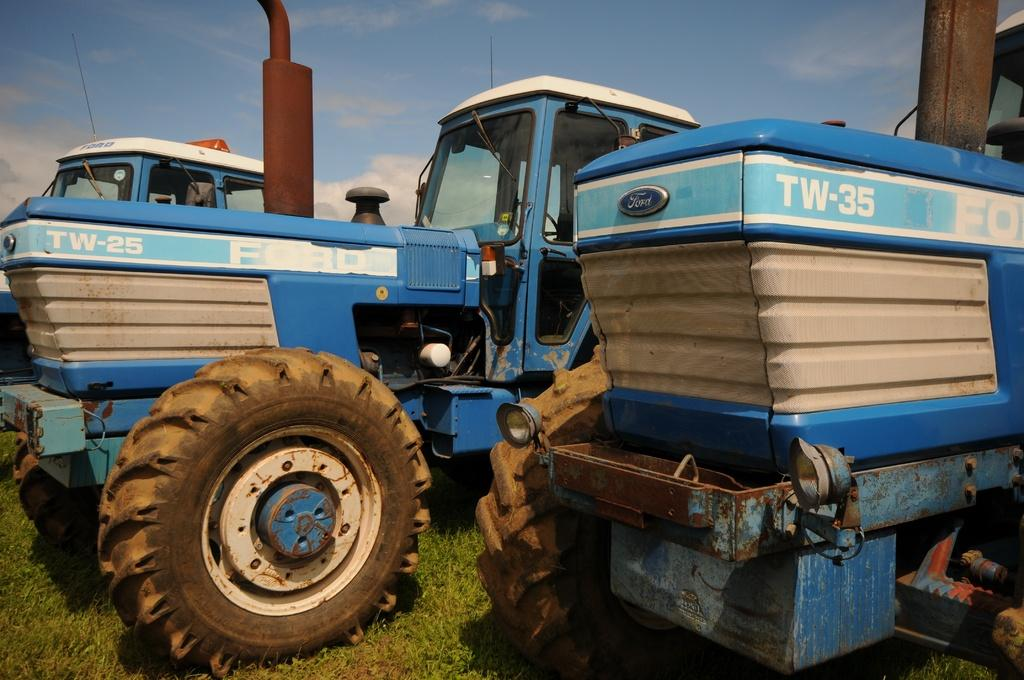What is located on the grass in the image? There are vehicles on the grass in the image. What colors can be seen on the vehicles? The vehicles have blue, white, and brown colors. What can be seen in the background of the image? There are clouds and the sky visible in the background of the image. What type of question is being asked by the clouds in the image? There are no questions being asked by the clouds in the image, as clouds do not have the ability to ask questions. 